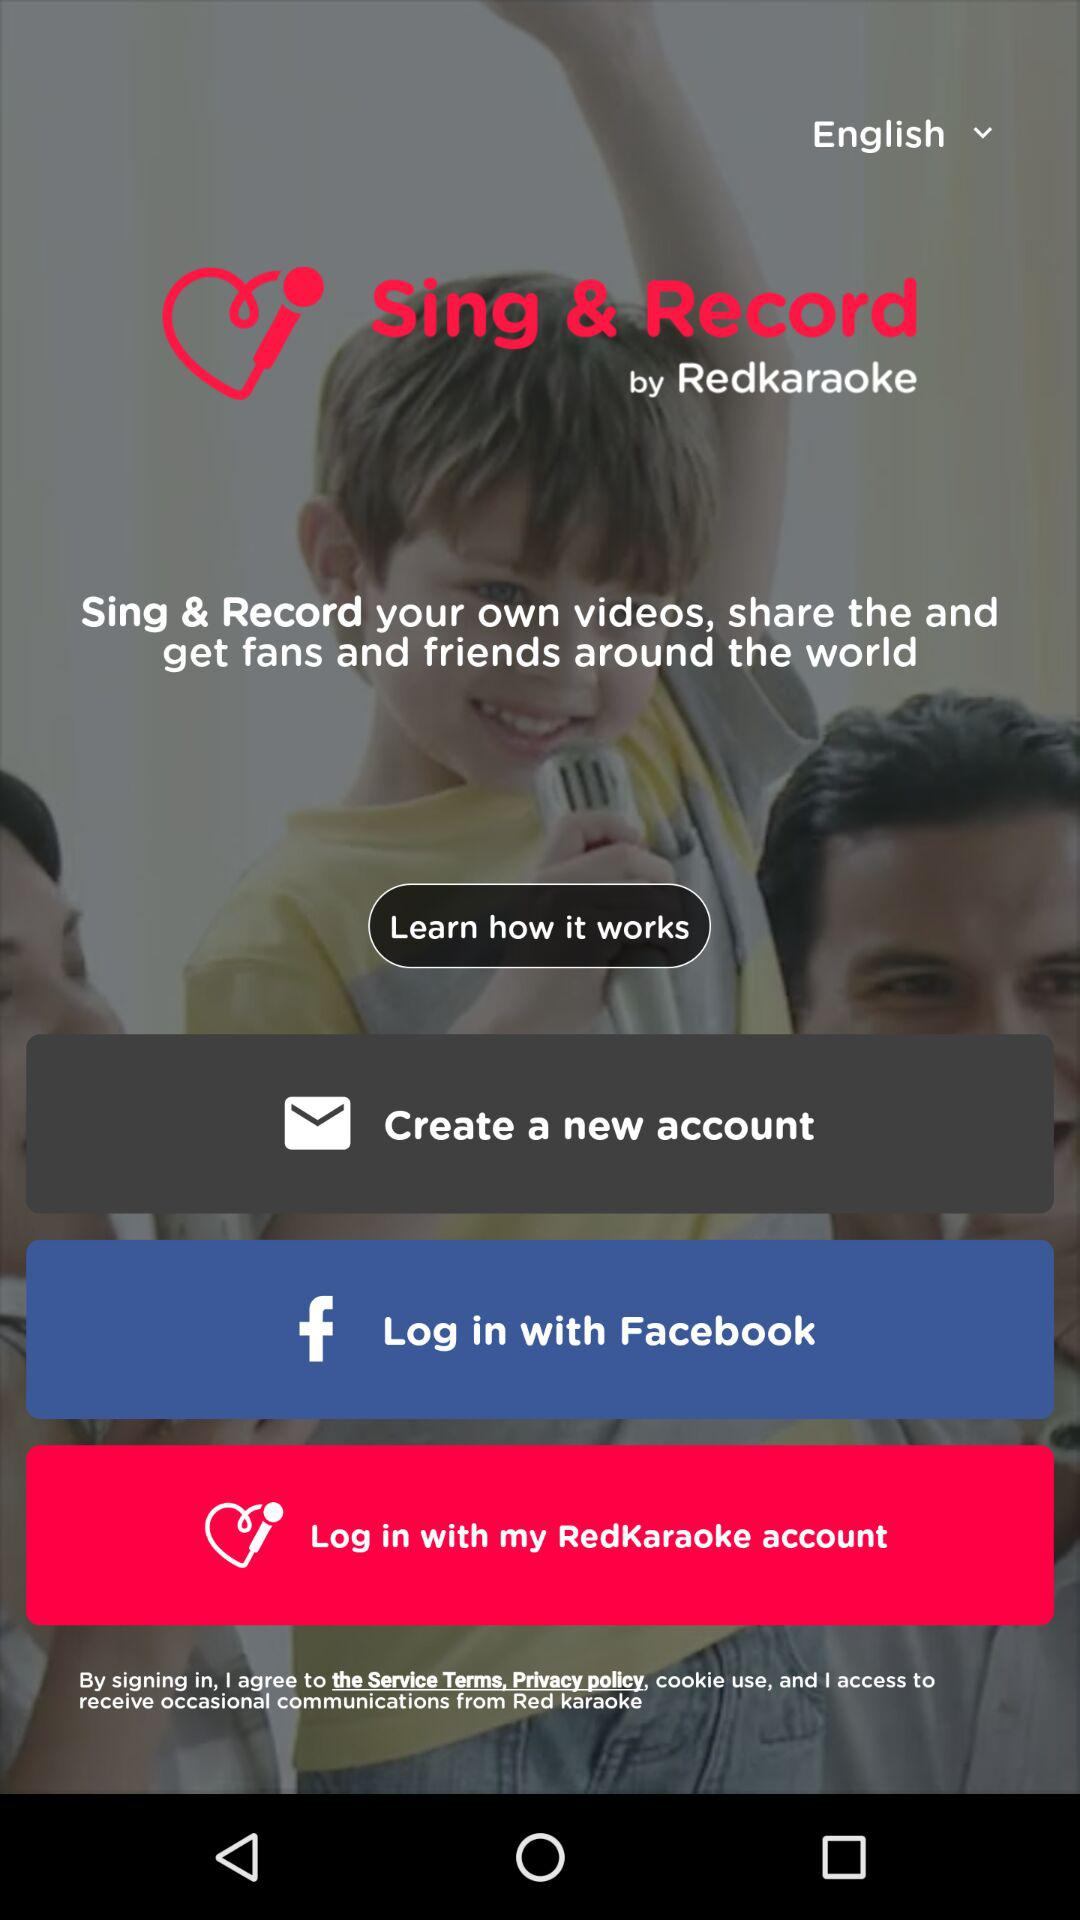In which language is the page? The page is in the English language. 